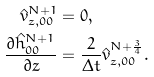<formula> <loc_0><loc_0><loc_500><loc_500>\hat { v } _ { z , 0 0 } ^ { N + 1 } & = 0 , \\ \frac { \partial \hat { h } ^ { N + 1 } _ { 0 0 } } { \partial z } & = \frac { 2 } { \Delta t } \hat { v } _ { z , 0 0 } ^ { N + \frac { 3 } { 4 } } .</formula> 